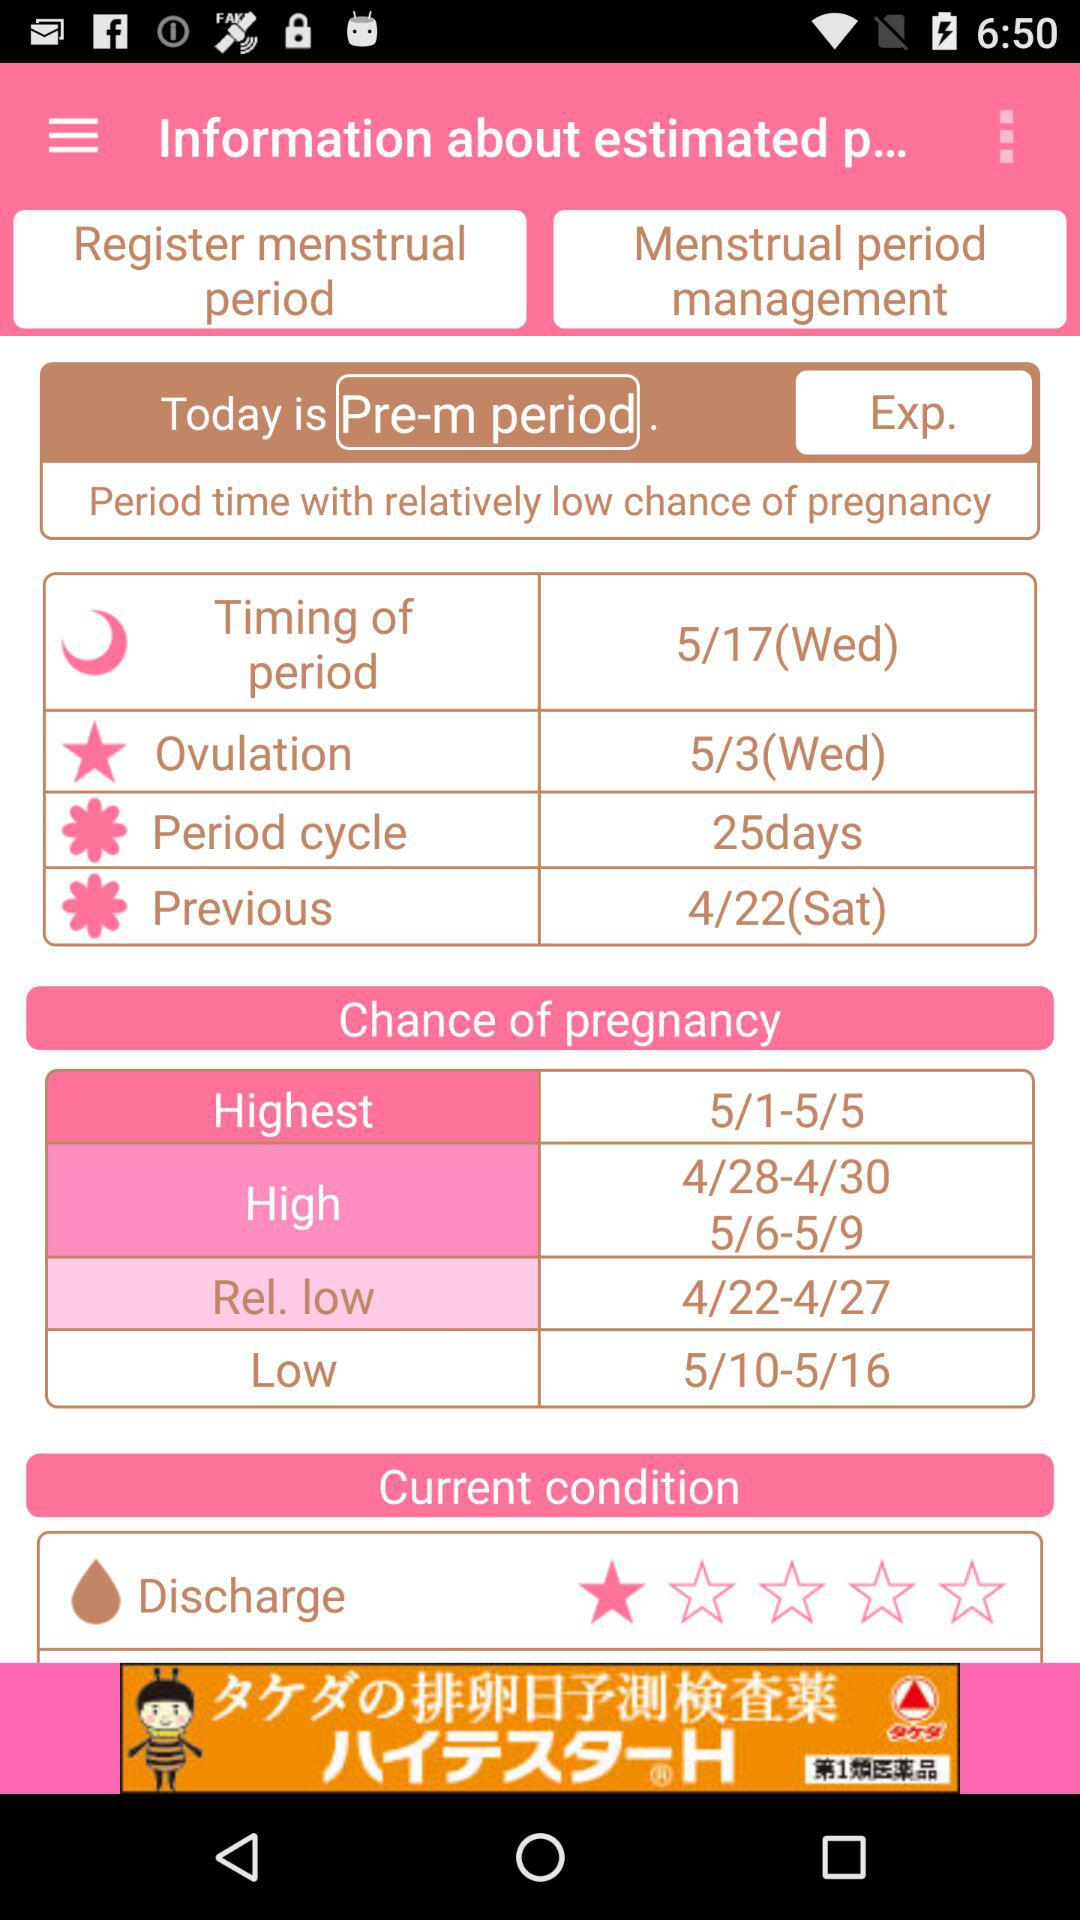What option is mentioned for the 25 days? The option is "Period cycle". 